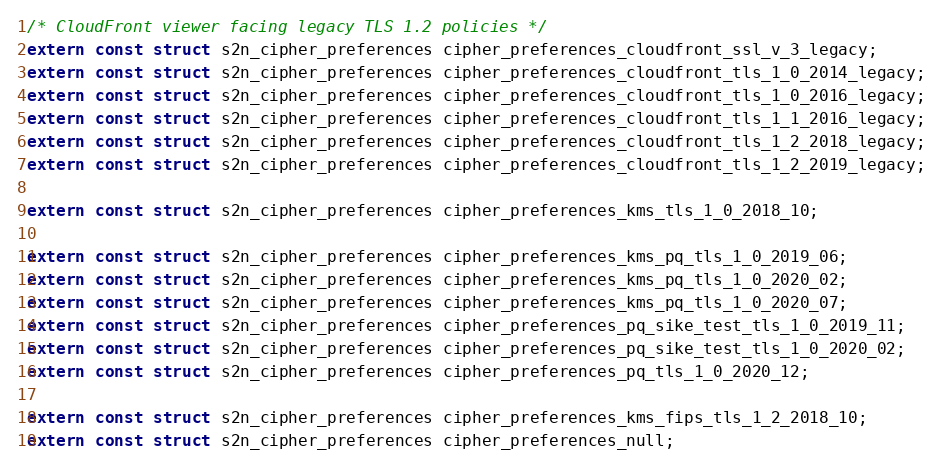<code> <loc_0><loc_0><loc_500><loc_500><_C_>
/* CloudFront viewer facing legacy TLS 1.2 policies */
extern const struct s2n_cipher_preferences cipher_preferences_cloudfront_ssl_v_3_legacy;
extern const struct s2n_cipher_preferences cipher_preferences_cloudfront_tls_1_0_2014_legacy;
extern const struct s2n_cipher_preferences cipher_preferences_cloudfront_tls_1_0_2016_legacy;
extern const struct s2n_cipher_preferences cipher_preferences_cloudfront_tls_1_1_2016_legacy;
extern const struct s2n_cipher_preferences cipher_preferences_cloudfront_tls_1_2_2018_legacy;
extern const struct s2n_cipher_preferences cipher_preferences_cloudfront_tls_1_2_2019_legacy;

extern const struct s2n_cipher_preferences cipher_preferences_kms_tls_1_0_2018_10;

extern const struct s2n_cipher_preferences cipher_preferences_kms_pq_tls_1_0_2019_06;
extern const struct s2n_cipher_preferences cipher_preferences_kms_pq_tls_1_0_2020_02;
extern const struct s2n_cipher_preferences cipher_preferences_kms_pq_tls_1_0_2020_07;
extern const struct s2n_cipher_preferences cipher_preferences_pq_sike_test_tls_1_0_2019_11;
extern const struct s2n_cipher_preferences cipher_preferences_pq_sike_test_tls_1_0_2020_02;
extern const struct s2n_cipher_preferences cipher_preferences_pq_tls_1_0_2020_12;

extern const struct s2n_cipher_preferences cipher_preferences_kms_fips_tls_1_2_2018_10;
extern const struct s2n_cipher_preferences cipher_preferences_null;

</code> 